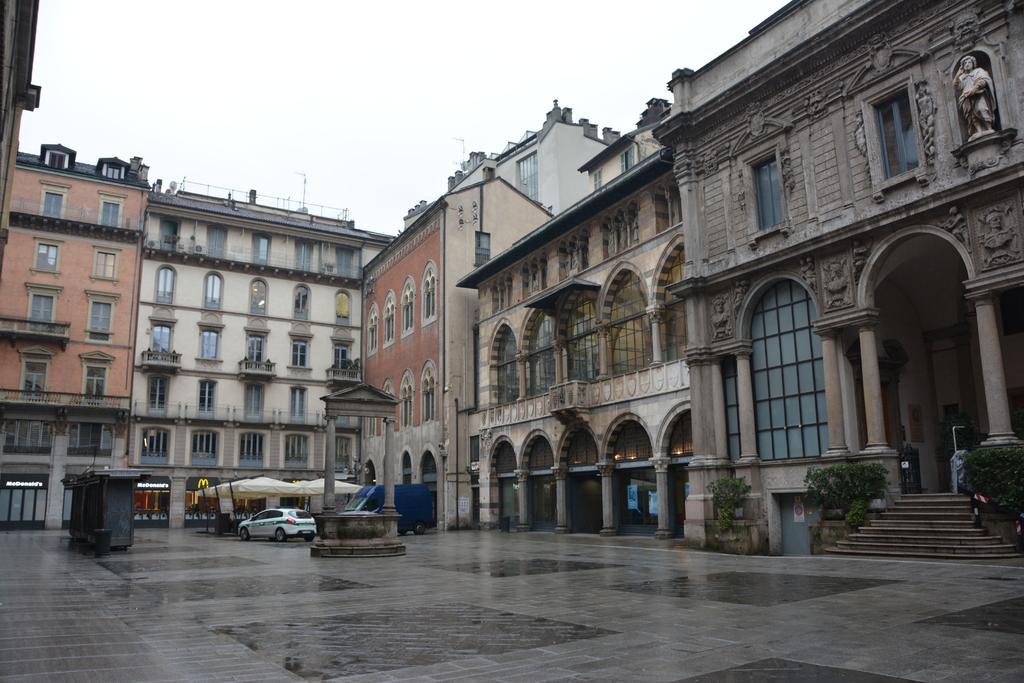Could you give a brief overview of what you see in this image? On the right side of the image there are stairs. There is a car and a few other objects. There is a memorial. In the background of the image there are buildings, plants and sky. At the bottom of the image there is a floor. 